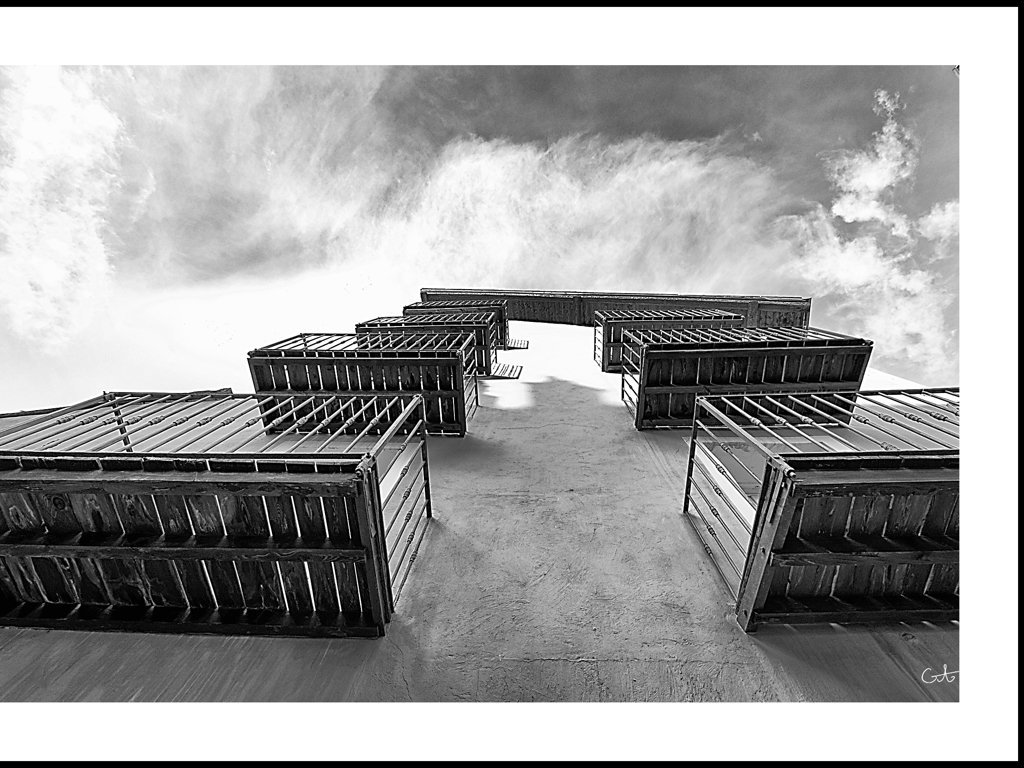Are there any quality issues with this image? Upon inspection, the image appears to be of high quality, with good contrast, sharpness, and clarity. There are no immediately obvious quality issues concerning resolution or visual artifacts. It’s taken with a creative perspective, looking up at a sharply defined building against a dynamic sky, which lends a dramatic and imposing feel to the composition. 